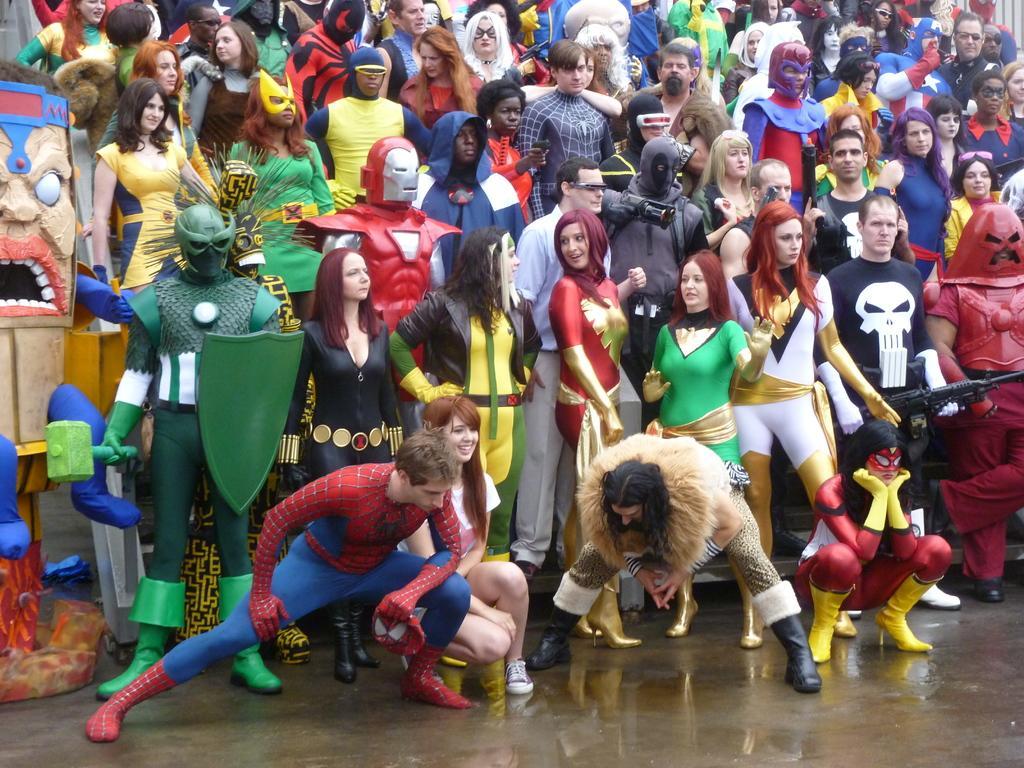Could you give a brief overview of what you see in this image? In this image we can see many people. Some are wearing costumes. Some are holding some objects in the hand. On the left side there is an object. 